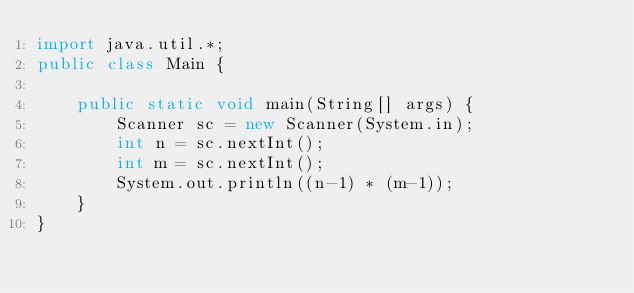<code> <loc_0><loc_0><loc_500><loc_500><_Java_>import java.util.*;
public class Main {
	
    public static void main(String[] args) {
        Scanner sc = new Scanner(System.in);
        int n = sc.nextInt();
        int m = sc.nextInt();
        System.out.println((n-1) * (m-1));
    }
}</code> 